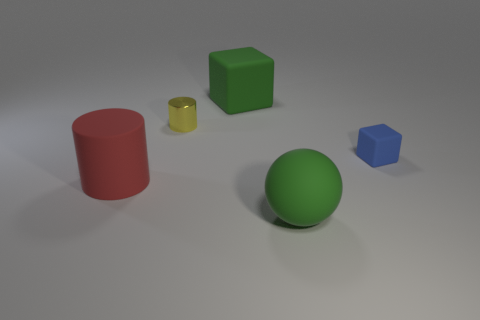Subtract all green blocks. How many blocks are left? 1 Add 5 cyan cubes. How many objects exist? 10 Subtract all cubes. How many objects are left? 3 Subtract all brown cylinders. How many blue blocks are left? 1 Add 5 large green rubber spheres. How many large green rubber spheres are left? 6 Add 2 big green spheres. How many big green spheres exist? 3 Subtract 0 yellow balls. How many objects are left? 5 Subtract all red cylinders. Subtract all yellow balls. How many cylinders are left? 1 Subtract all small rubber cubes. Subtract all small blue blocks. How many objects are left? 3 